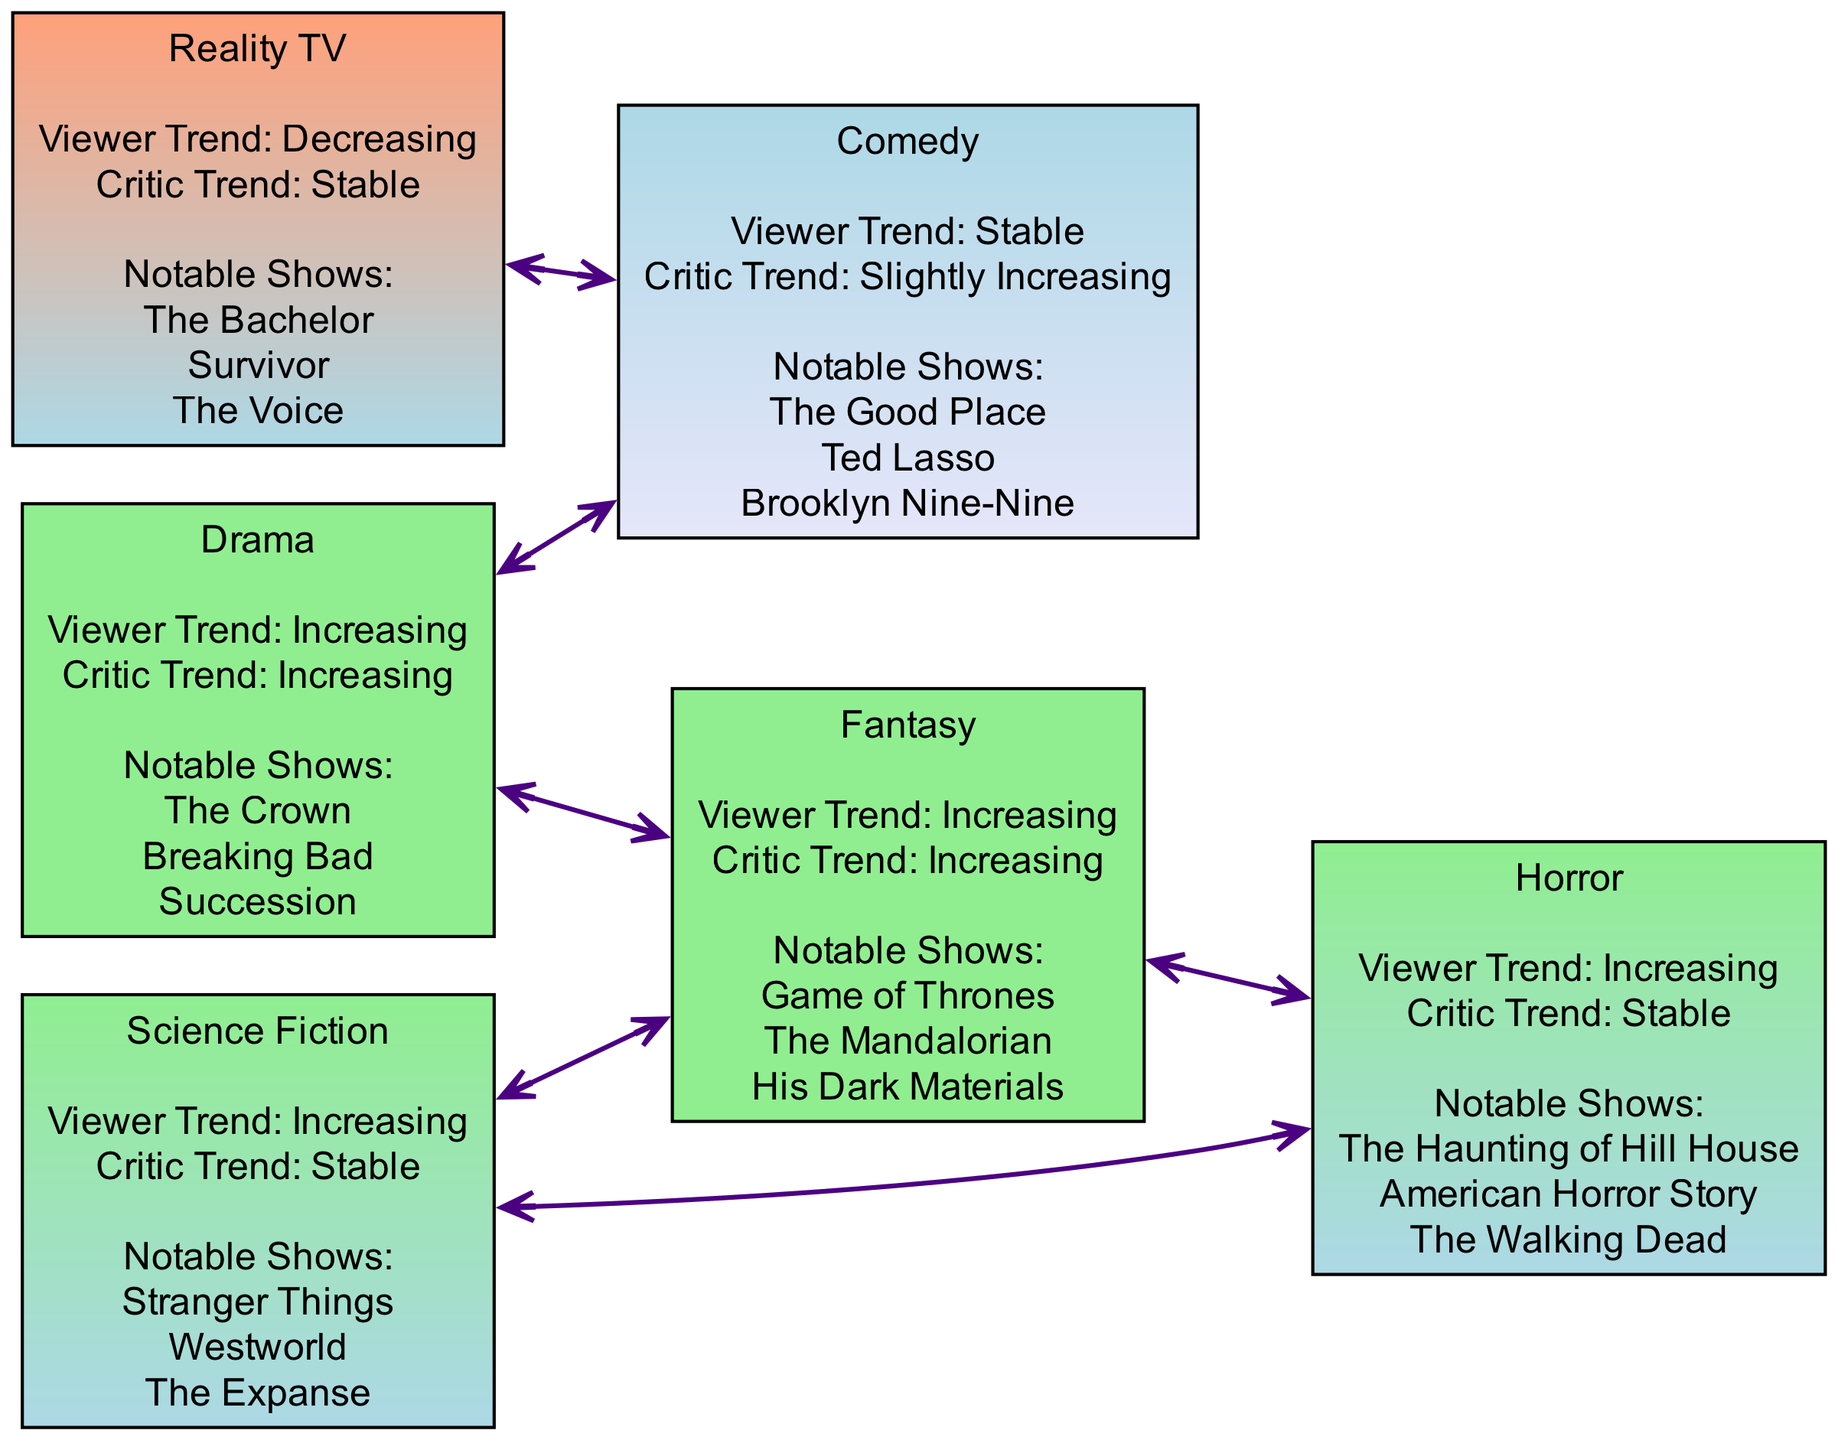What are three notable shows in the Drama genre? The Drama genre lists its notable shows, which include The Crown, Breaking Bad, and Succession. You can find them in the information provided for the Drama node in the diagram.
Answer: The Crown, Breaking Bad, Succession Which genre has a decreasing viewer rating trend? The Reality TV genre is the only one listed with a decreasing viewer rating trend. This information can be found within its attributes in the diagram.
Answer: Reality TV What is the viewer rating trend for the Fantasy genre? According to the diagram, the Fantasy genre has an increasing viewer rating trend, which is indicated in its attributes.
Answer: Increasing How many edges connect the Drama genre to other genres? The Drama genre connects to three other genres: Comedy, Fantasy, and Reality TV, which can be counted through the edges leading from the Drama node in the diagram.
Answer: 3 Which genre has a stable critical rating trend? The Reality TV genre has a stable critical rating trend. This detail is specified within its attributes found in the diagram.
Answer: Reality TV Are there any genres with both viewer and critical rating trends increasing? Yes, both the Drama and Fantasy genres exhibit increasing trends for viewer and critical ratings. You can compare the attributes of both genres in the diagram to find this information.
Answer: Drama, Fantasy Which genres are connected to the Science Fiction genre? The Science Fiction genre is connected to both the Fantasy and Horror genres, indicated by the edges in the diagram leading from the Science Fiction node.
Answer: Fantasy, Horror What color represents an increasing viewer rating trend in this diagram? The color that represents an increasing viewer rating trend is light green, as specified in the color mapping section associated with the diagram.
Answer: Light green How many different genres are depicted in the diagram? There are six different genres depicted in the diagram: Drama, Comedy, Science Fiction, Reality TV, Fantasy, and Horror. You can count the nodes listed in the diagram to arrive at this number.
Answer: 6 